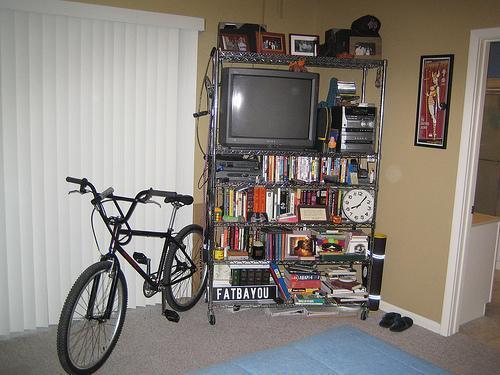How many pictures are hanging on the wall?
Give a very brief answer. 1. 